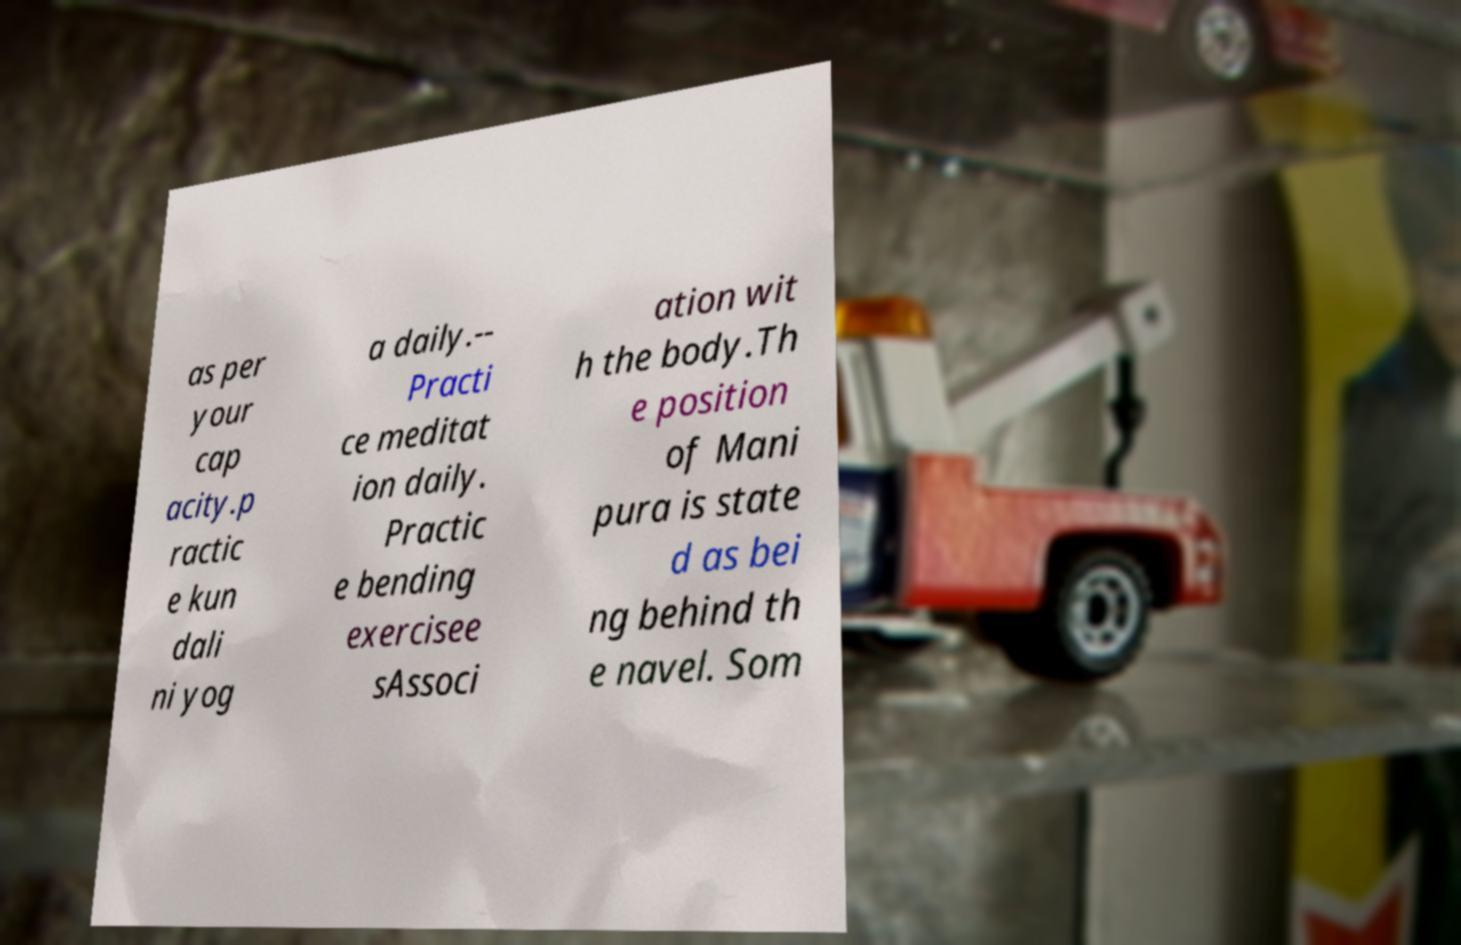For documentation purposes, I need the text within this image transcribed. Could you provide that? as per your cap acity.p ractic e kun dali ni yog a daily.-- Practi ce meditat ion daily. Practic e bending exercisee sAssoci ation wit h the body.Th e position of Mani pura is state d as bei ng behind th e navel. Som 